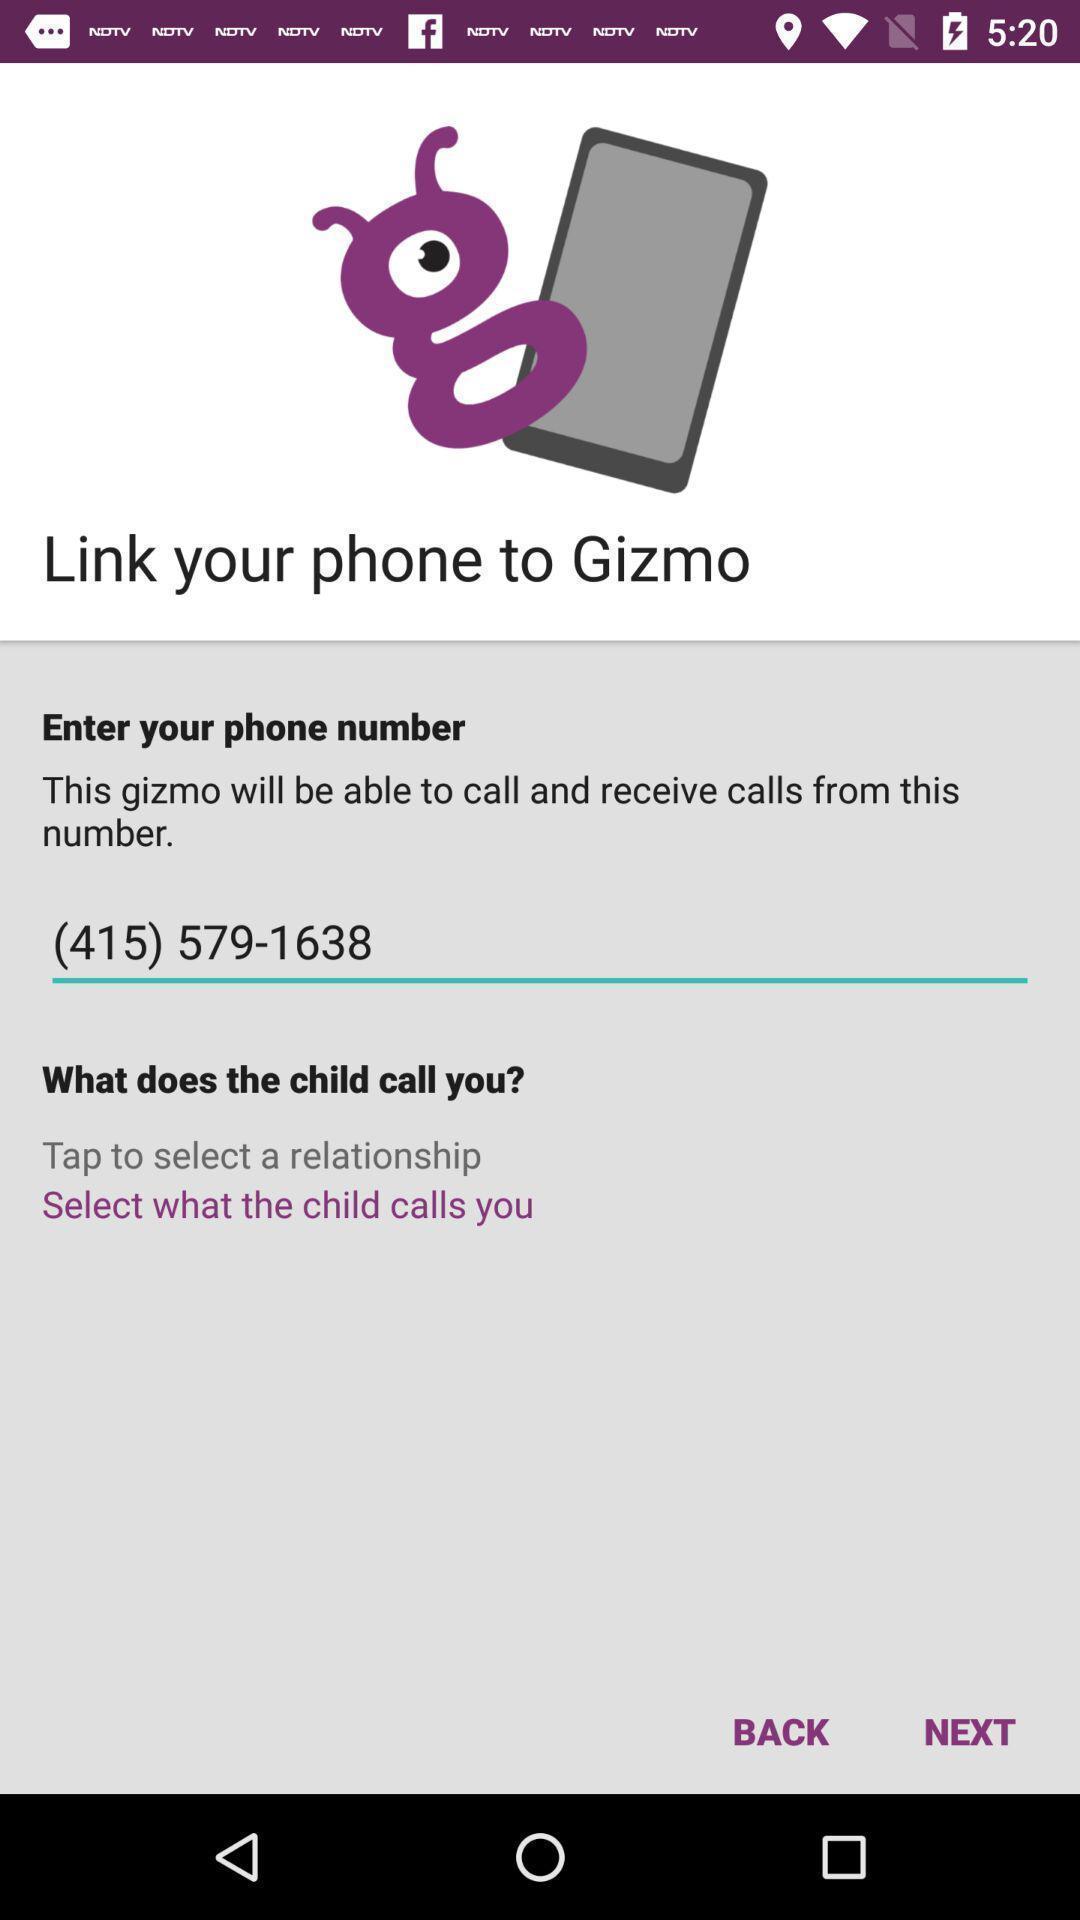Summarize the information in this screenshot. Welcome page of a call app. 